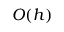<formula> <loc_0><loc_0><loc_500><loc_500>O ( h )</formula> 